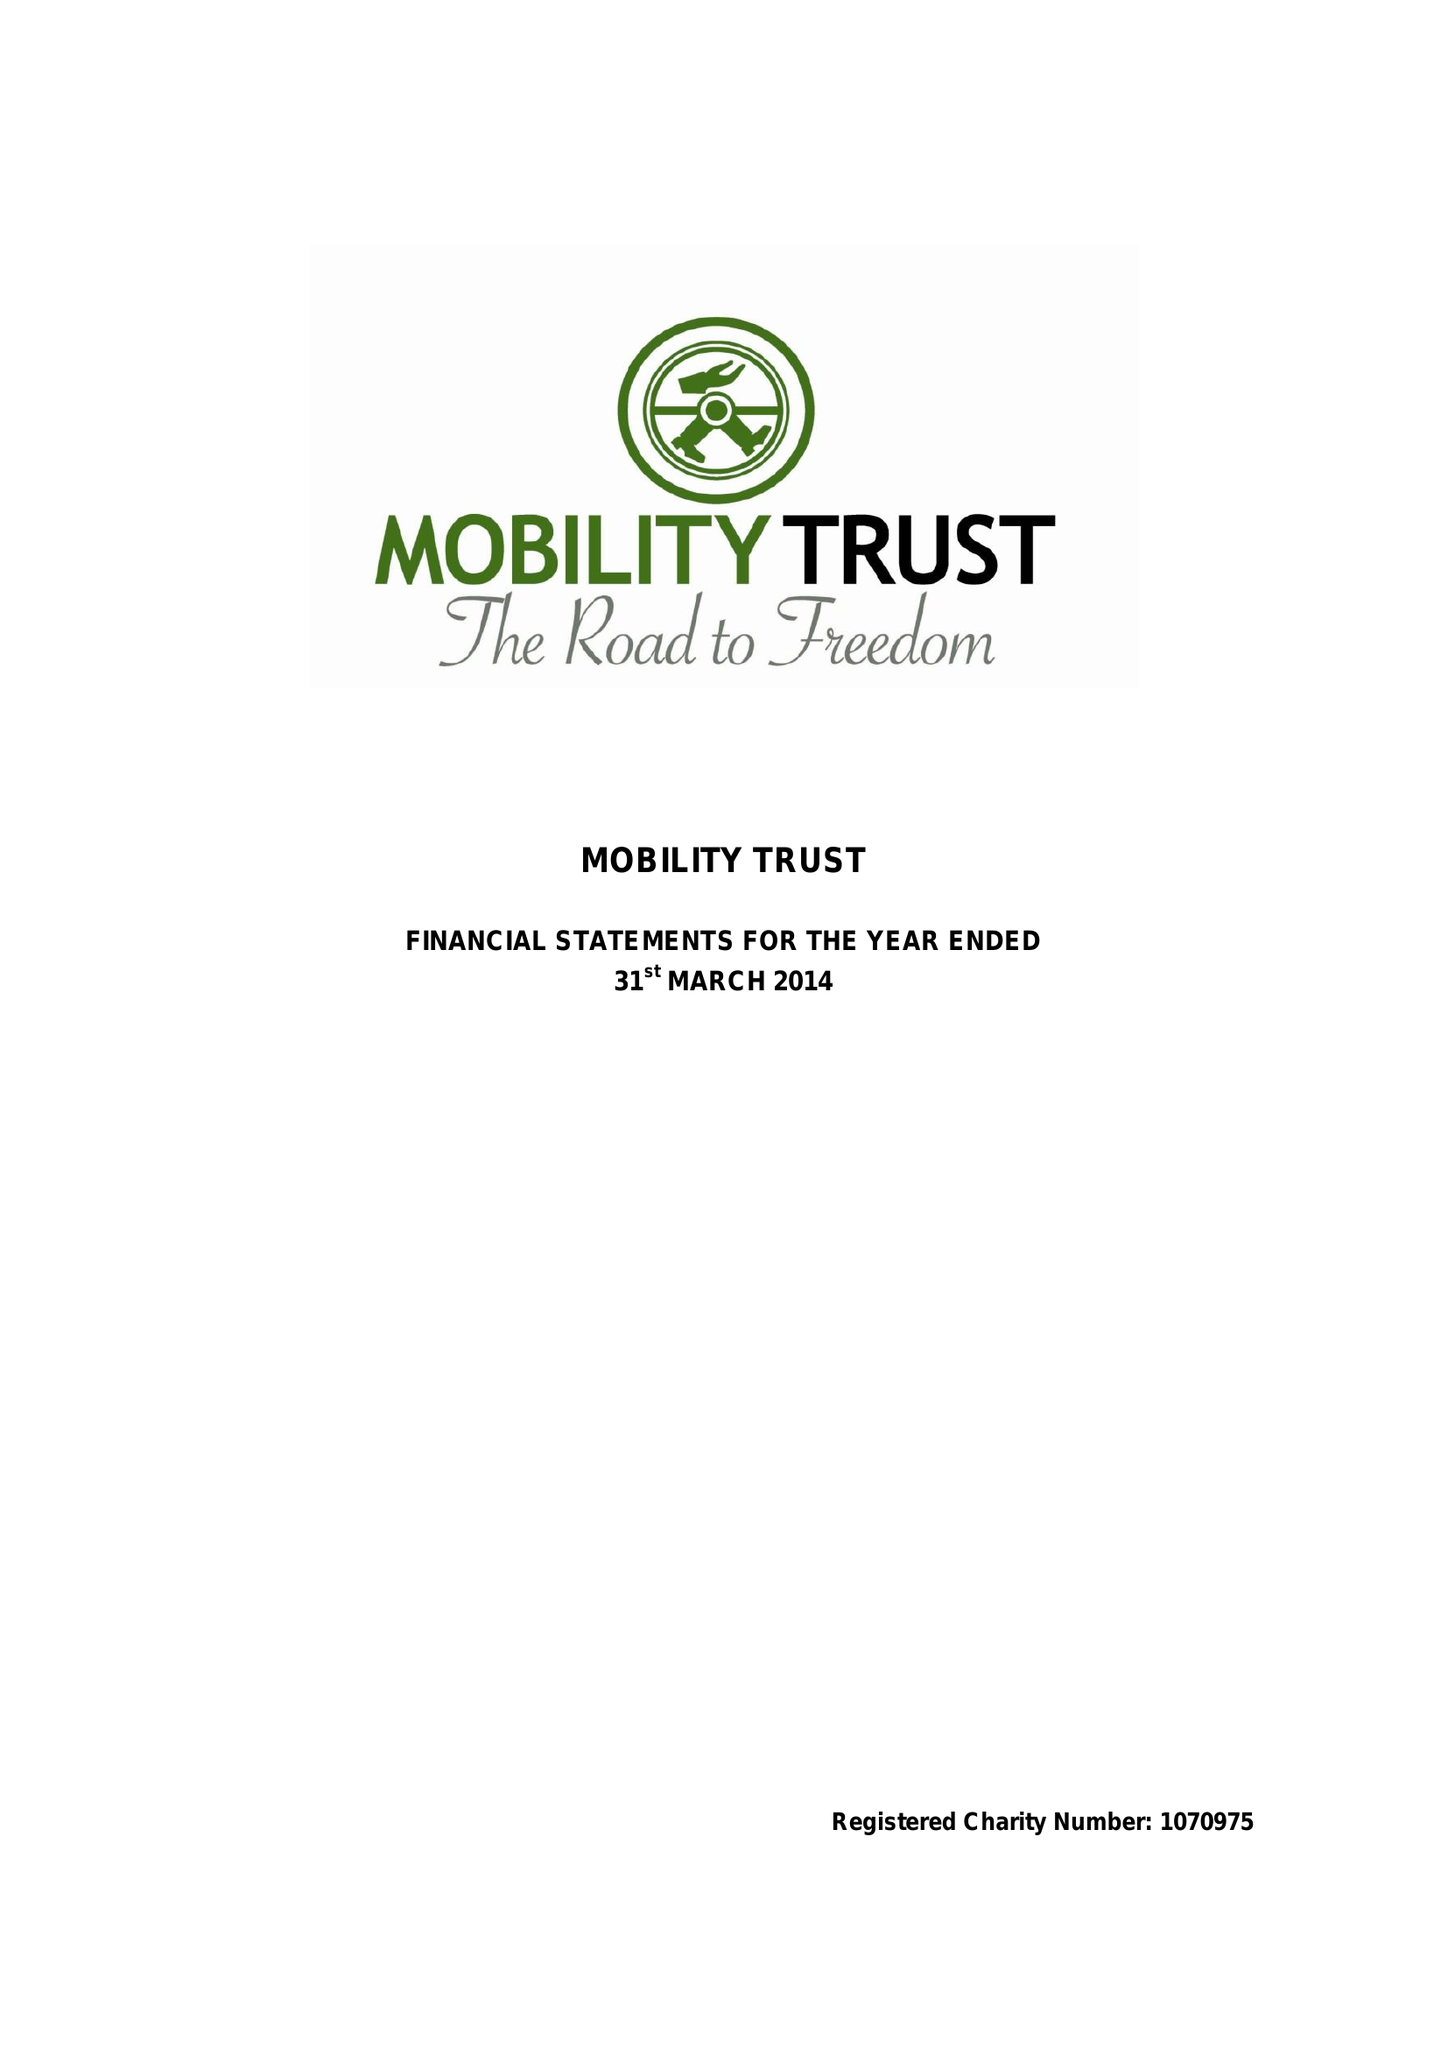What is the value for the report_date?
Answer the question using a single word or phrase. 2014-03-31 